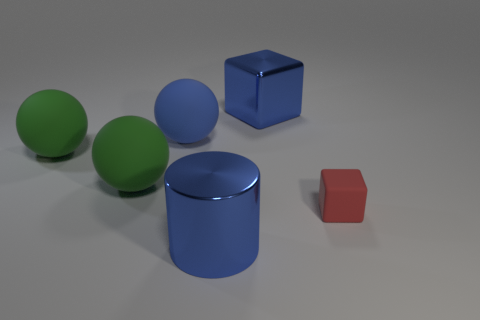Add 1 big green metal spheres. How many objects exist? 7 Subtract all blocks. How many objects are left? 4 Subtract 1 blue cylinders. How many objects are left? 5 Subtract all tiny blue rubber things. Subtract all matte objects. How many objects are left? 2 Add 2 metal things. How many metal things are left? 4 Add 6 small blocks. How many small blocks exist? 7 